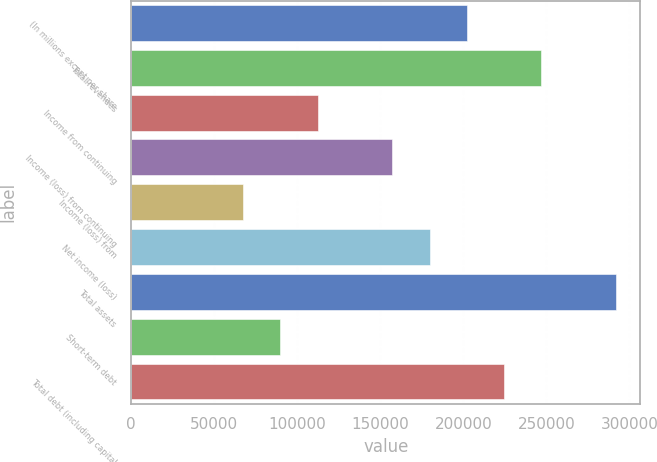<chart> <loc_0><loc_0><loc_500><loc_500><bar_chart><fcel>(In millions except per share<fcel>Total revenues<fcel>Income from continuing<fcel>Income (loss) from continuing<fcel>Income (loss) from<fcel>Net income (loss)<fcel>Total assets<fcel>Short-term debt<fcel>Total debt (including capital<nl><fcel>202118<fcel>247033<fcel>112288<fcel>157203<fcel>67373.4<fcel>179661<fcel>291948<fcel>89830.9<fcel>224576<nl></chart> 